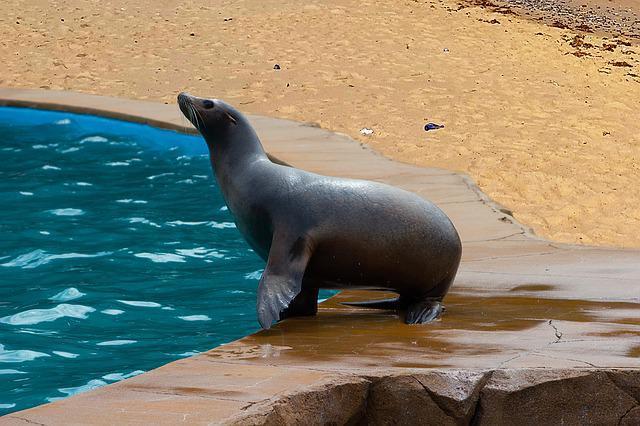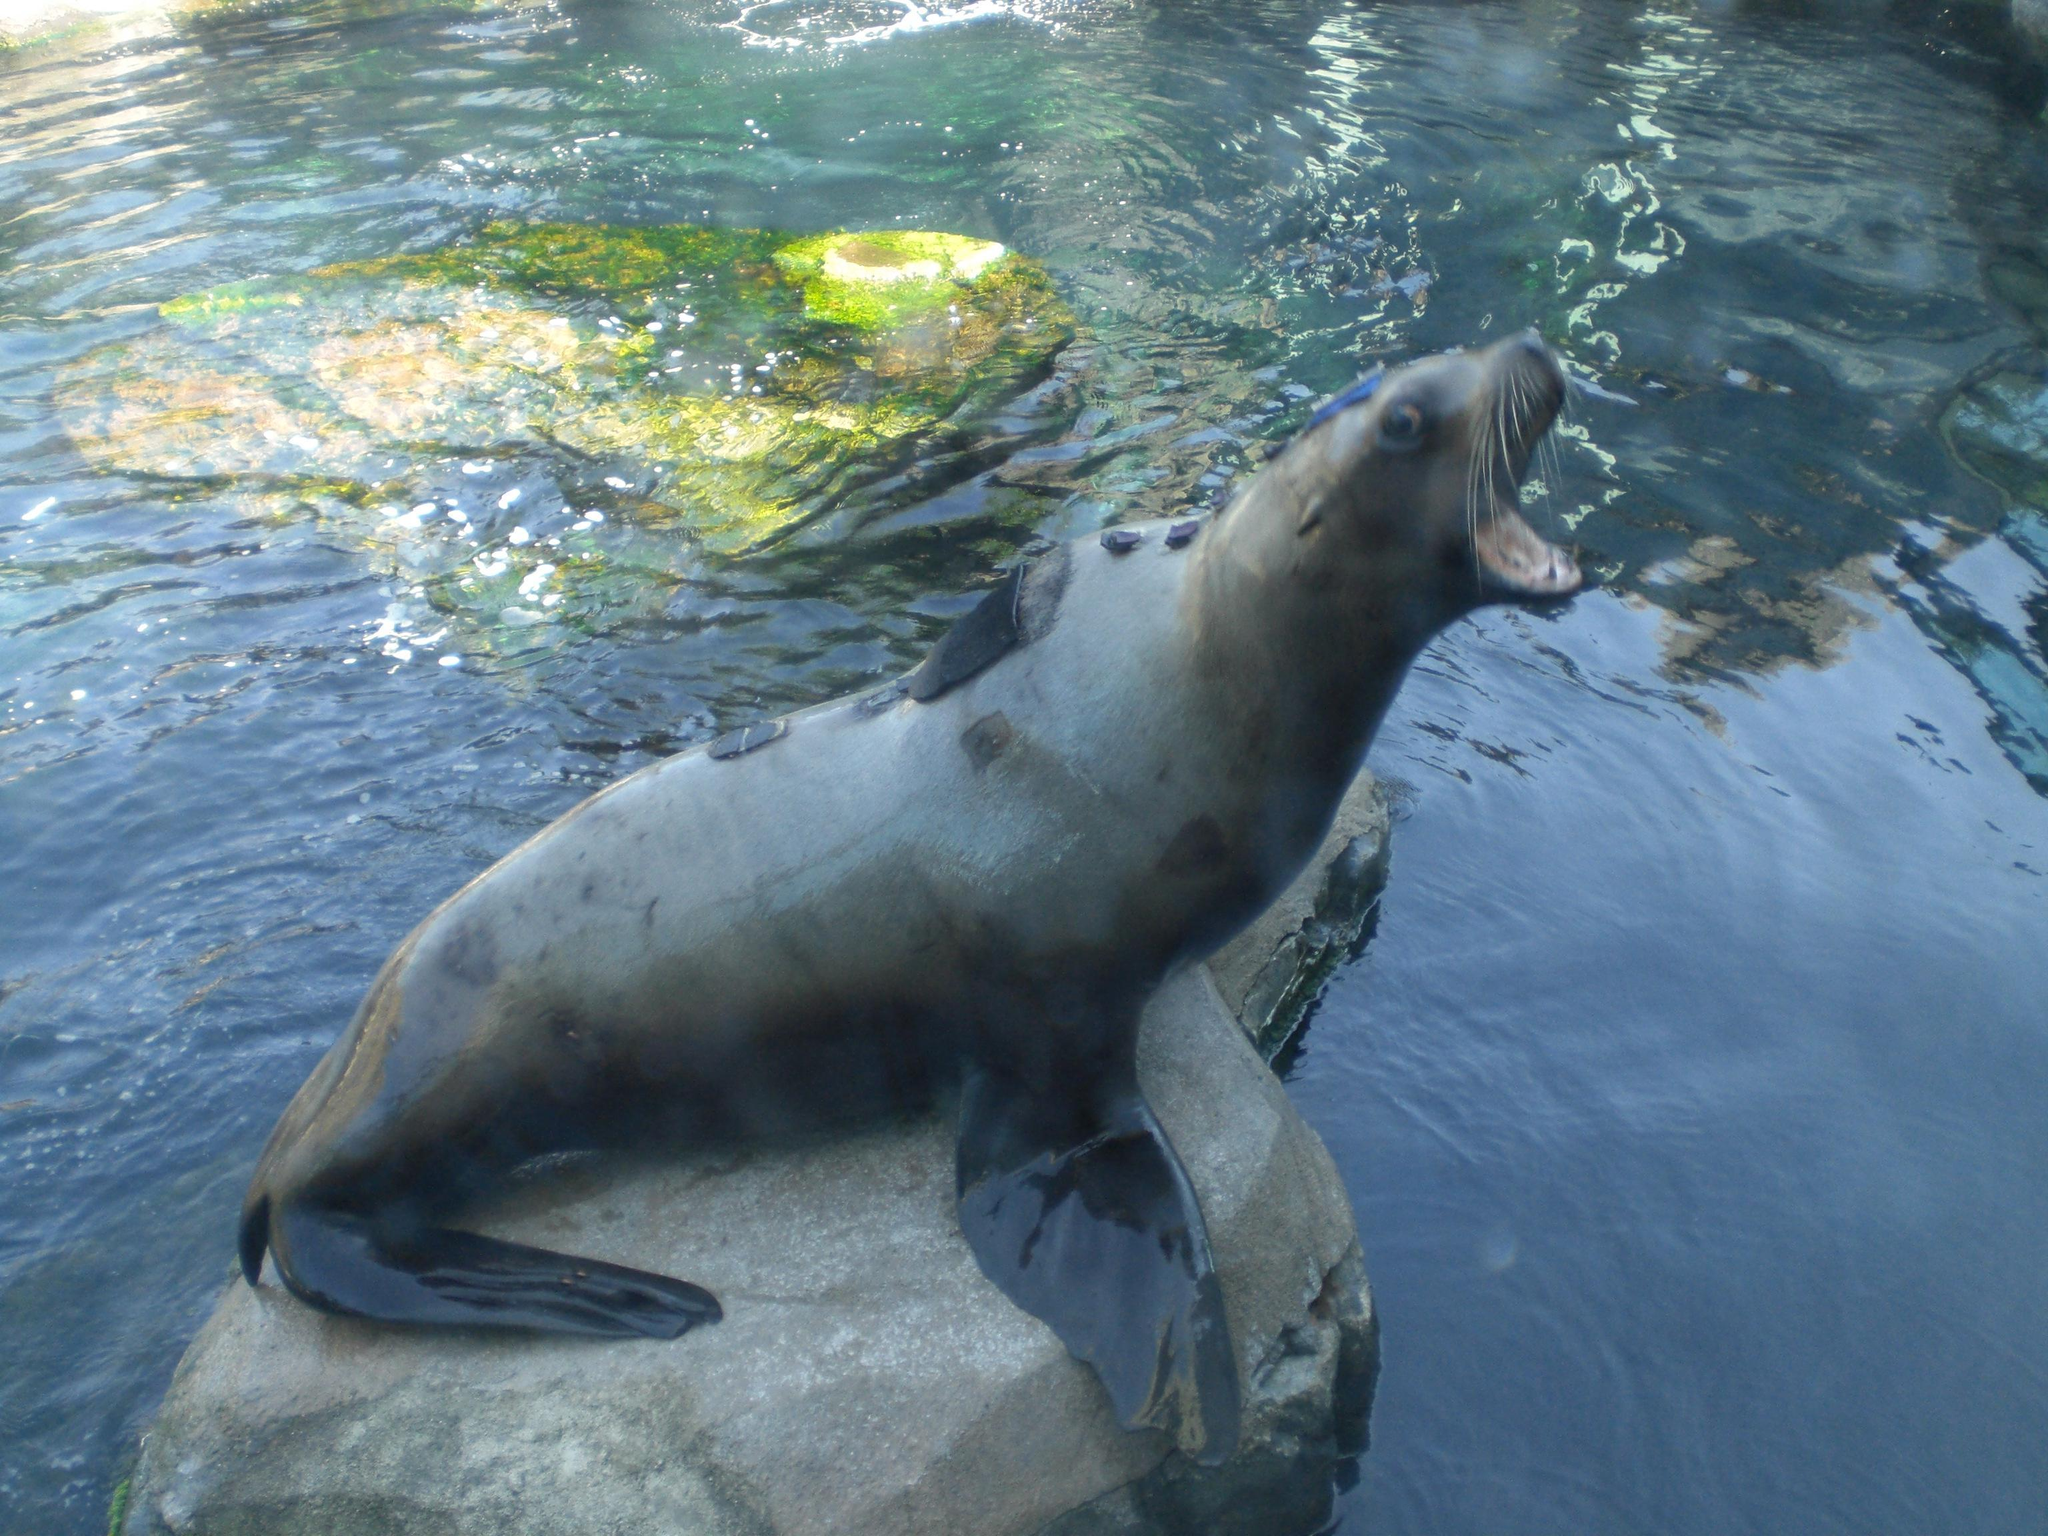The first image is the image on the left, the second image is the image on the right. For the images displayed, is the sentence "At least one of the seals is in the water." factually correct? Answer yes or no. No. The first image is the image on the left, the second image is the image on the right. Examine the images to the left and right. Is the description "An image includes one reclining seal next to a seal with raised head and shoulders." accurate? Answer yes or no. No. 